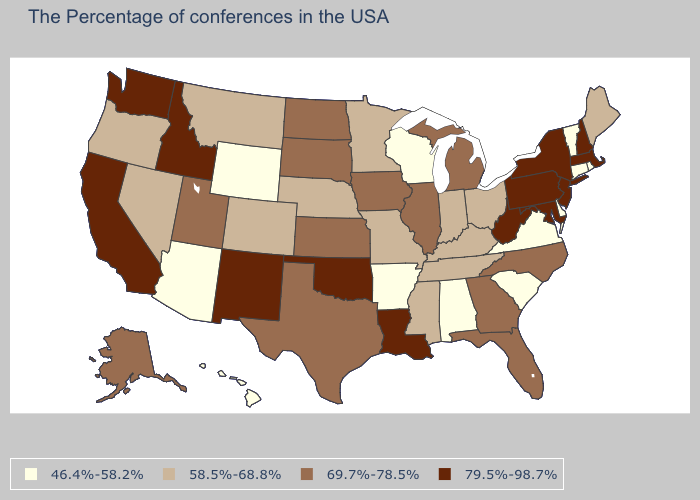Does Nevada have the highest value in the USA?
Answer briefly. No. Which states have the lowest value in the USA?
Answer briefly. Rhode Island, Vermont, Connecticut, Delaware, Virginia, South Carolina, Alabama, Wisconsin, Arkansas, Wyoming, Arizona, Hawaii. Does Vermont have a higher value than Pennsylvania?
Answer briefly. No. What is the value of Vermont?
Keep it brief. 46.4%-58.2%. Name the states that have a value in the range 58.5%-68.8%?
Answer briefly. Maine, Ohio, Kentucky, Indiana, Tennessee, Mississippi, Missouri, Minnesota, Nebraska, Colorado, Montana, Nevada, Oregon. What is the highest value in states that border Florida?
Keep it brief. 69.7%-78.5%. What is the highest value in states that border New York?
Write a very short answer. 79.5%-98.7%. What is the value of Mississippi?
Short answer required. 58.5%-68.8%. Does Kansas have the highest value in the MidWest?
Answer briefly. Yes. Which states have the lowest value in the West?
Concise answer only. Wyoming, Arizona, Hawaii. Name the states that have a value in the range 79.5%-98.7%?
Answer briefly. Massachusetts, New Hampshire, New York, New Jersey, Maryland, Pennsylvania, West Virginia, Louisiana, Oklahoma, New Mexico, Idaho, California, Washington. Among the states that border Wyoming , which have the lowest value?
Answer briefly. Nebraska, Colorado, Montana. What is the value of Pennsylvania?
Quick response, please. 79.5%-98.7%. Name the states that have a value in the range 69.7%-78.5%?
Answer briefly. North Carolina, Florida, Georgia, Michigan, Illinois, Iowa, Kansas, Texas, South Dakota, North Dakota, Utah, Alaska. Name the states that have a value in the range 69.7%-78.5%?
Be succinct. North Carolina, Florida, Georgia, Michigan, Illinois, Iowa, Kansas, Texas, South Dakota, North Dakota, Utah, Alaska. 